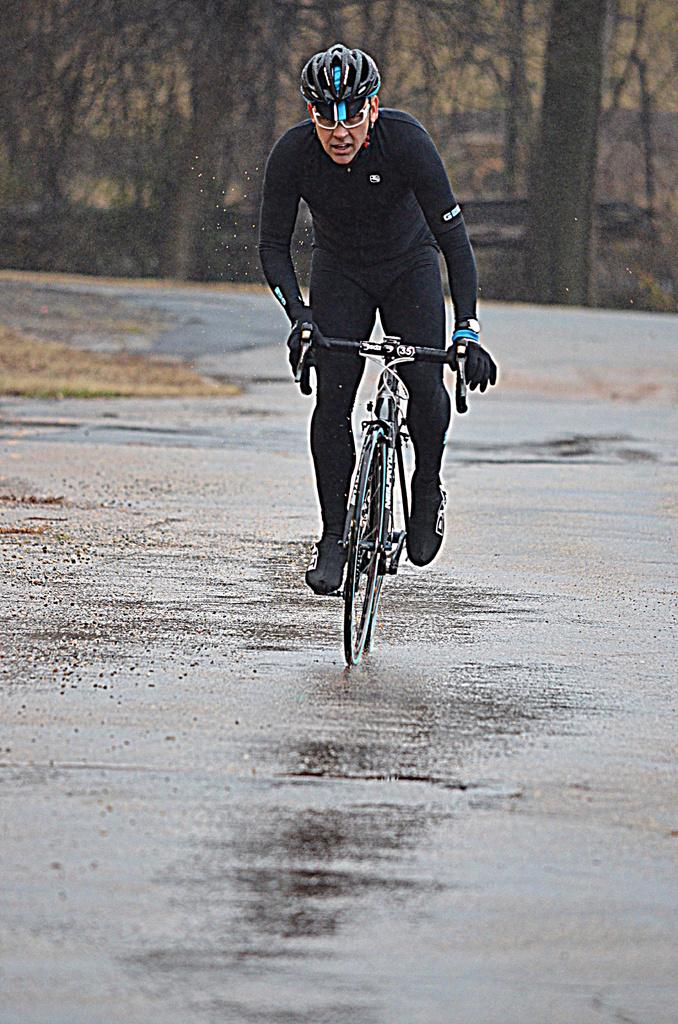Who is the person in the image? There is a man in the image. What is the man doing in the image? The man is riding a bicycle. Where is the man riding the bicycle? The bicycle is on a road. What type of meat is the man grilling on the side of the road in the image? There is no meat or grill present in the image; the man is riding a bicycle on a road. 